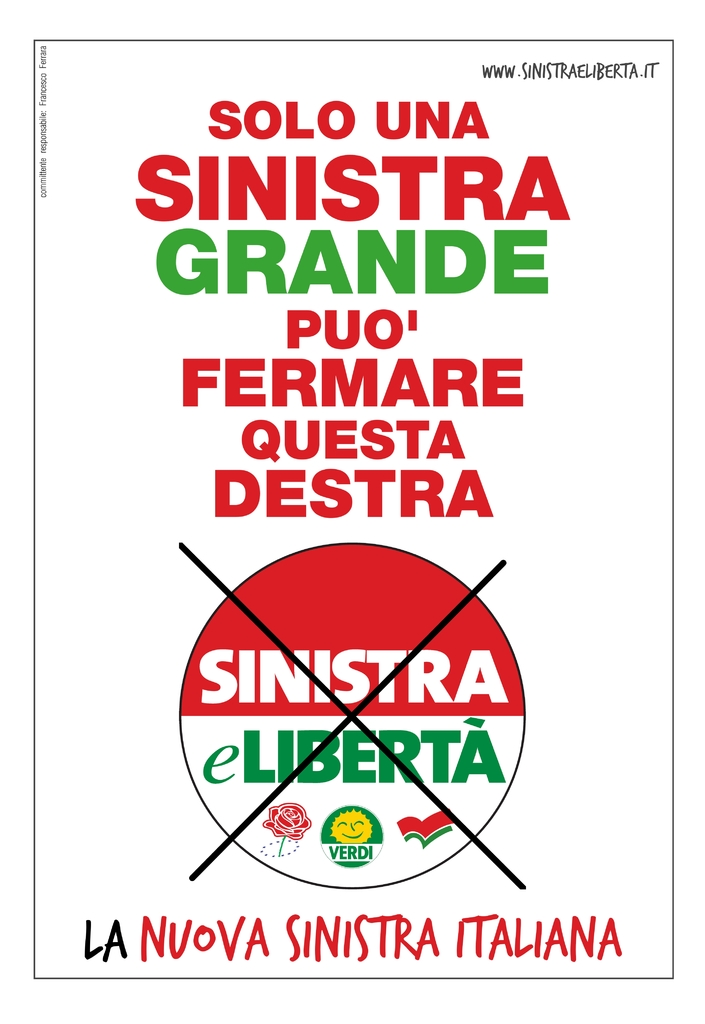What does the phrase 'Solo Una Sinistra Grande Puo' Fermare Questa Destra' suggest about the political message of the poster? The phrase translates to 'Only a strong left can stop this right,' indicating a call to consolidate the left-wing forces to counter the right-wing politics in Italy, emphasizing urgency and unity in political action. 